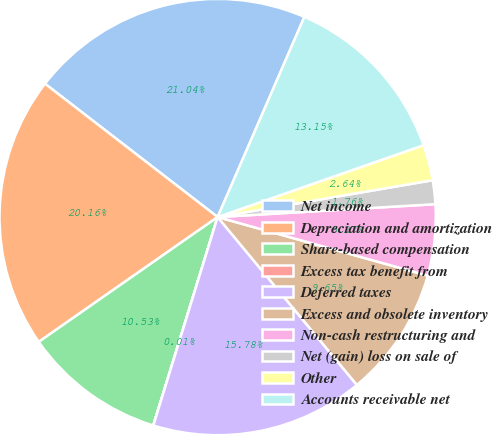Convert chart. <chart><loc_0><loc_0><loc_500><loc_500><pie_chart><fcel>Net income<fcel>Depreciation and amortization<fcel>Share-based compensation<fcel>Excess tax benefit from<fcel>Deferred taxes<fcel>Excess and obsolete inventory<fcel>Non-cash restructuring and<fcel>Net (gain) loss on sale of<fcel>Other<fcel>Accounts receivable net<nl><fcel>21.04%<fcel>20.16%<fcel>10.53%<fcel>0.01%<fcel>15.78%<fcel>9.65%<fcel>5.27%<fcel>1.76%<fcel>2.64%<fcel>13.15%<nl></chart> 